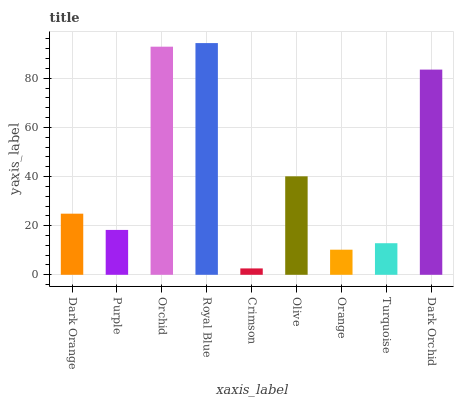Is Crimson the minimum?
Answer yes or no. Yes. Is Royal Blue the maximum?
Answer yes or no. Yes. Is Purple the minimum?
Answer yes or no. No. Is Purple the maximum?
Answer yes or no. No. Is Dark Orange greater than Purple?
Answer yes or no. Yes. Is Purple less than Dark Orange?
Answer yes or no. Yes. Is Purple greater than Dark Orange?
Answer yes or no. No. Is Dark Orange less than Purple?
Answer yes or no. No. Is Dark Orange the high median?
Answer yes or no. Yes. Is Dark Orange the low median?
Answer yes or no. Yes. Is Purple the high median?
Answer yes or no. No. Is Royal Blue the low median?
Answer yes or no. No. 